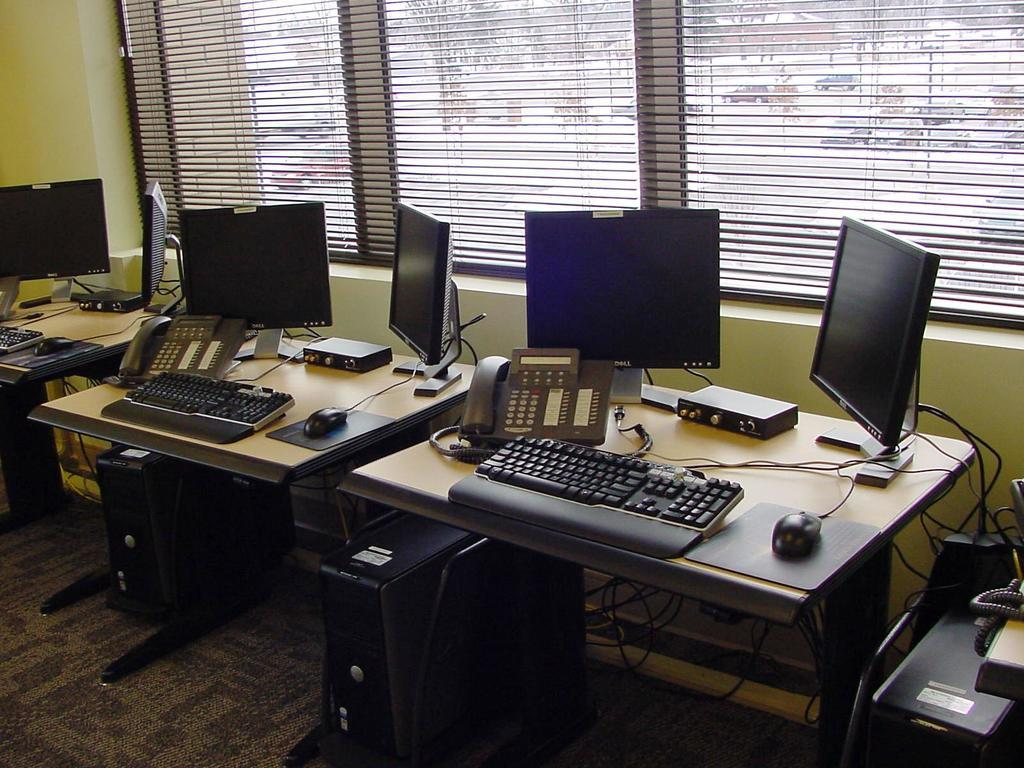What color is the wall that can be seen in the image? The wall in the image is yellow. What feature allows natural light to enter the room in the image? There is a window in the image. What type of furniture is present in the image? There are tables in the image. What electronic devices can be seen on the tables? Keyboards, phones, and laptops are present on the tables. Are there any giants visible in the image? No, there are no giants present in the image. What type of linen can be seen draped over the tables in the image? There is no linen visible in the image; only tables, keyboards, phones, and laptops are present. 